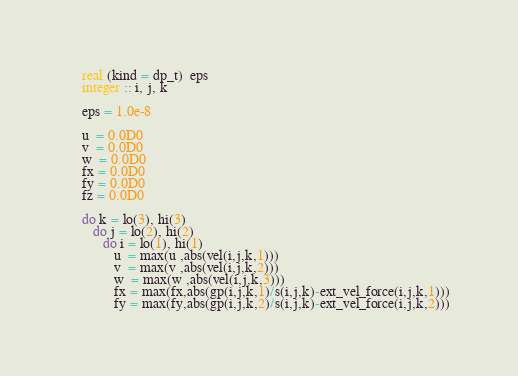<code> <loc_0><loc_0><loc_500><loc_500><_FORTRAN_>    real (kind = dp_t)  eps
    integer :: i, j, k

    eps = 1.0e-8

    u  = 0.0D0 
    v  = 0.0D0 
    w  = 0.0D0
    fx = 0.0D0 
    fy = 0.0D0 
    fz = 0.0D0 

    do k = lo(3), hi(3)
       do j = lo(2), hi(2)
          do i = lo(1), hi(1)
             u  = max(u ,abs(vel(i,j,k,1)))
             v  = max(v ,abs(vel(i,j,k,2)))
             w  = max(w ,abs(vel(i,j,k,3)))
             fx = max(fx,abs(gp(i,j,k,1)/s(i,j,k)-ext_vel_force(i,j,k,1)))
             fy = max(fy,abs(gp(i,j,k,2)/s(i,j,k)-ext_vel_force(i,j,k,2)))</code> 